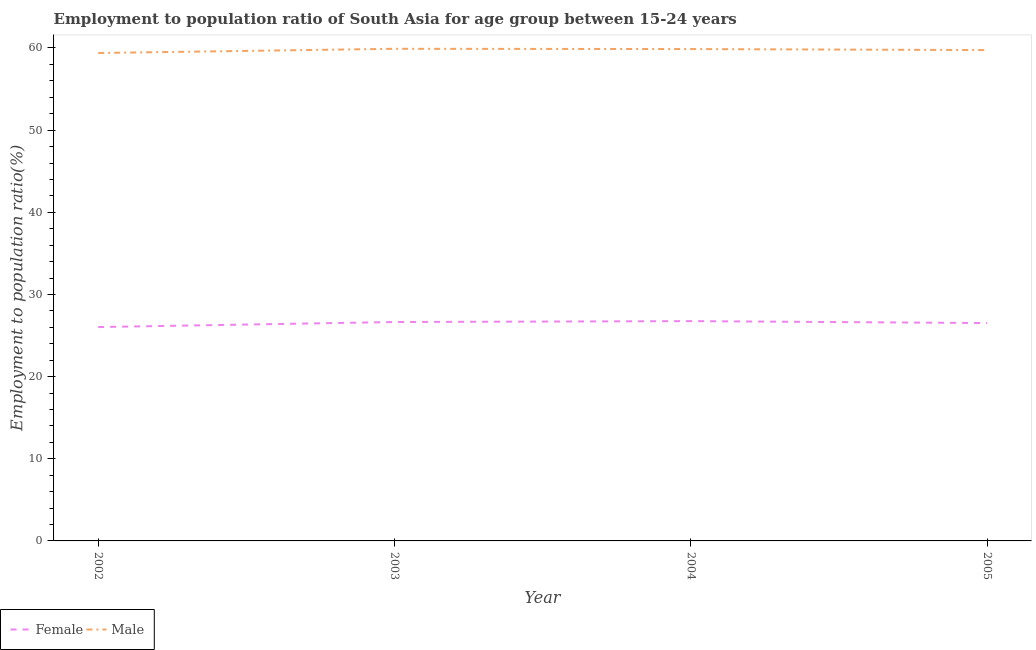How many different coloured lines are there?
Offer a very short reply. 2. Does the line corresponding to employment to population ratio(male) intersect with the line corresponding to employment to population ratio(female)?
Make the answer very short. No. Is the number of lines equal to the number of legend labels?
Provide a short and direct response. Yes. What is the employment to population ratio(male) in 2004?
Offer a terse response. 59.87. Across all years, what is the maximum employment to population ratio(female)?
Offer a terse response. 26.75. Across all years, what is the minimum employment to population ratio(male)?
Your answer should be very brief. 59.39. In which year was the employment to population ratio(male) maximum?
Your response must be concise. 2003. In which year was the employment to population ratio(female) minimum?
Your response must be concise. 2002. What is the total employment to population ratio(female) in the graph?
Make the answer very short. 105.95. What is the difference between the employment to population ratio(male) in 2002 and that in 2003?
Give a very brief answer. -0.51. What is the difference between the employment to population ratio(female) in 2004 and the employment to population ratio(male) in 2002?
Offer a very short reply. -32.64. What is the average employment to population ratio(male) per year?
Your answer should be very brief. 59.73. In the year 2004, what is the difference between the employment to population ratio(male) and employment to population ratio(female)?
Ensure brevity in your answer.  33.12. What is the ratio of the employment to population ratio(male) in 2002 to that in 2005?
Offer a terse response. 0.99. Is the employment to population ratio(female) in 2002 less than that in 2004?
Make the answer very short. Yes. What is the difference between the highest and the second highest employment to population ratio(female)?
Make the answer very short. 0.11. What is the difference between the highest and the lowest employment to population ratio(male)?
Your response must be concise. 0.51. Is the sum of the employment to population ratio(male) in 2002 and 2003 greater than the maximum employment to population ratio(female) across all years?
Provide a short and direct response. Yes. Does the employment to population ratio(female) monotonically increase over the years?
Your response must be concise. No. How many years are there in the graph?
Provide a succinct answer. 4. What is the difference between two consecutive major ticks on the Y-axis?
Keep it short and to the point. 10. Are the values on the major ticks of Y-axis written in scientific E-notation?
Offer a terse response. No. Does the graph contain grids?
Keep it short and to the point. No. Where does the legend appear in the graph?
Keep it short and to the point. Bottom left. How many legend labels are there?
Your response must be concise. 2. What is the title of the graph?
Provide a short and direct response. Employment to population ratio of South Asia for age group between 15-24 years. What is the Employment to population ratio(%) in Female in 2002?
Ensure brevity in your answer.  26.03. What is the Employment to population ratio(%) in Male in 2002?
Offer a very short reply. 59.39. What is the Employment to population ratio(%) of Female in 2003?
Provide a succinct answer. 26.65. What is the Employment to population ratio(%) in Male in 2003?
Your response must be concise. 59.9. What is the Employment to population ratio(%) in Female in 2004?
Keep it short and to the point. 26.75. What is the Employment to population ratio(%) of Male in 2004?
Offer a terse response. 59.87. What is the Employment to population ratio(%) of Female in 2005?
Offer a very short reply. 26.52. What is the Employment to population ratio(%) in Male in 2005?
Make the answer very short. 59.74. Across all years, what is the maximum Employment to population ratio(%) in Female?
Ensure brevity in your answer.  26.75. Across all years, what is the maximum Employment to population ratio(%) in Male?
Offer a very short reply. 59.9. Across all years, what is the minimum Employment to population ratio(%) in Female?
Your answer should be very brief. 26.03. Across all years, what is the minimum Employment to population ratio(%) in Male?
Provide a succinct answer. 59.39. What is the total Employment to population ratio(%) of Female in the graph?
Ensure brevity in your answer.  105.95. What is the total Employment to population ratio(%) in Male in the graph?
Keep it short and to the point. 238.91. What is the difference between the Employment to population ratio(%) of Female in 2002 and that in 2003?
Provide a succinct answer. -0.62. What is the difference between the Employment to population ratio(%) in Male in 2002 and that in 2003?
Keep it short and to the point. -0.51. What is the difference between the Employment to population ratio(%) in Female in 2002 and that in 2004?
Keep it short and to the point. -0.72. What is the difference between the Employment to population ratio(%) of Male in 2002 and that in 2004?
Offer a terse response. -0.48. What is the difference between the Employment to population ratio(%) of Female in 2002 and that in 2005?
Provide a short and direct response. -0.49. What is the difference between the Employment to population ratio(%) in Male in 2002 and that in 2005?
Ensure brevity in your answer.  -0.35. What is the difference between the Employment to population ratio(%) of Female in 2003 and that in 2004?
Keep it short and to the point. -0.11. What is the difference between the Employment to population ratio(%) of Male in 2003 and that in 2004?
Your answer should be compact. 0.03. What is the difference between the Employment to population ratio(%) of Female in 2003 and that in 2005?
Offer a terse response. 0.13. What is the difference between the Employment to population ratio(%) in Male in 2003 and that in 2005?
Provide a succinct answer. 0.16. What is the difference between the Employment to population ratio(%) of Female in 2004 and that in 2005?
Make the answer very short. 0.23. What is the difference between the Employment to population ratio(%) of Male in 2004 and that in 2005?
Your answer should be compact. 0.13. What is the difference between the Employment to population ratio(%) of Female in 2002 and the Employment to population ratio(%) of Male in 2003?
Your answer should be very brief. -33.87. What is the difference between the Employment to population ratio(%) in Female in 2002 and the Employment to population ratio(%) in Male in 2004?
Your response must be concise. -33.84. What is the difference between the Employment to population ratio(%) of Female in 2002 and the Employment to population ratio(%) of Male in 2005?
Your answer should be very brief. -33.71. What is the difference between the Employment to population ratio(%) of Female in 2003 and the Employment to population ratio(%) of Male in 2004?
Ensure brevity in your answer.  -33.22. What is the difference between the Employment to population ratio(%) in Female in 2003 and the Employment to population ratio(%) in Male in 2005?
Ensure brevity in your answer.  -33.1. What is the difference between the Employment to population ratio(%) in Female in 2004 and the Employment to population ratio(%) in Male in 2005?
Provide a succinct answer. -32.99. What is the average Employment to population ratio(%) of Female per year?
Your response must be concise. 26.49. What is the average Employment to population ratio(%) in Male per year?
Keep it short and to the point. 59.73. In the year 2002, what is the difference between the Employment to population ratio(%) of Female and Employment to population ratio(%) of Male?
Provide a short and direct response. -33.36. In the year 2003, what is the difference between the Employment to population ratio(%) of Female and Employment to population ratio(%) of Male?
Keep it short and to the point. -33.26. In the year 2004, what is the difference between the Employment to population ratio(%) in Female and Employment to population ratio(%) in Male?
Your answer should be compact. -33.12. In the year 2005, what is the difference between the Employment to population ratio(%) of Female and Employment to population ratio(%) of Male?
Offer a very short reply. -33.22. What is the ratio of the Employment to population ratio(%) of Female in 2002 to that in 2003?
Offer a very short reply. 0.98. What is the ratio of the Employment to population ratio(%) of Female in 2002 to that in 2004?
Offer a very short reply. 0.97. What is the ratio of the Employment to population ratio(%) of Male in 2002 to that in 2004?
Your response must be concise. 0.99. What is the ratio of the Employment to population ratio(%) in Female in 2002 to that in 2005?
Provide a succinct answer. 0.98. What is the ratio of the Employment to population ratio(%) of Male in 2002 to that in 2005?
Keep it short and to the point. 0.99. What is the ratio of the Employment to population ratio(%) of Male in 2003 to that in 2005?
Offer a very short reply. 1. What is the ratio of the Employment to population ratio(%) in Female in 2004 to that in 2005?
Make the answer very short. 1.01. What is the ratio of the Employment to population ratio(%) in Male in 2004 to that in 2005?
Give a very brief answer. 1. What is the difference between the highest and the second highest Employment to population ratio(%) in Female?
Keep it short and to the point. 0.11. What is the difference between the highest and the second highest Employment to population ratio(%) in Male?
Your response must be concise. 0.03. What is the difference between the highest and the lowest Employment to population ratio(%) in Female?
Provide a succinct answer. 0.72. What is the difference between the highest and the lowest Employment to population ratio(%) in Male?
Make the answer very short. 0.51. 